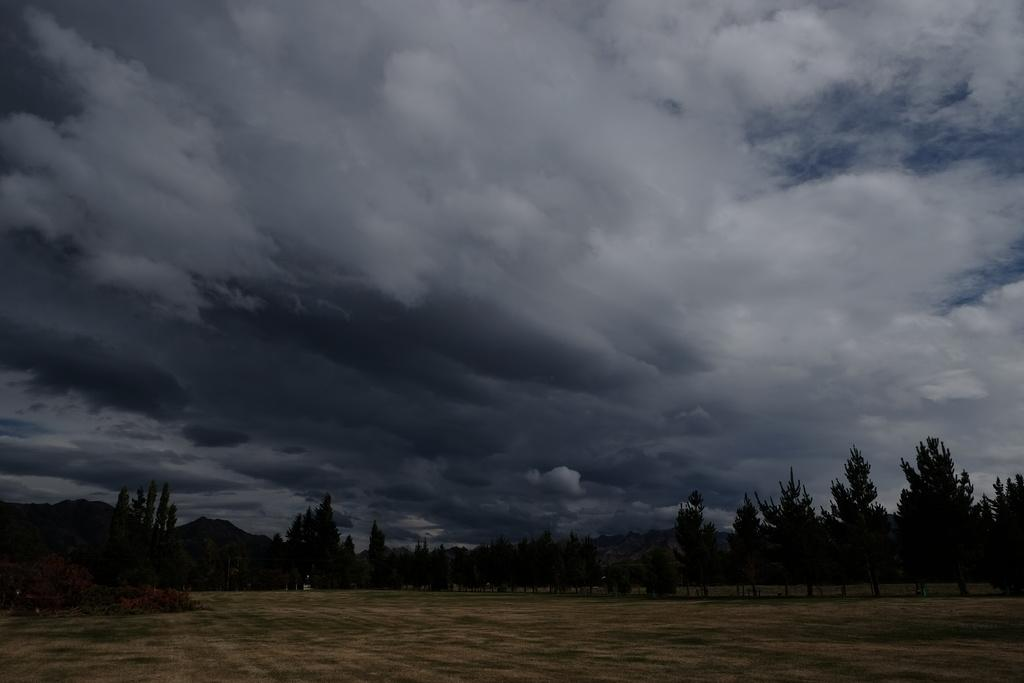What type of vegetation can be seen in the image? There are trees in the image. What else can be seen on the ground in the image? There is grass in the image. What is visible in the background of the image? The sky is visible in the image. What can be observed in the sky? Clouds are present in the sky. What type of print can be seen on the grass in the image? There is no print visible on the grass in the image. 